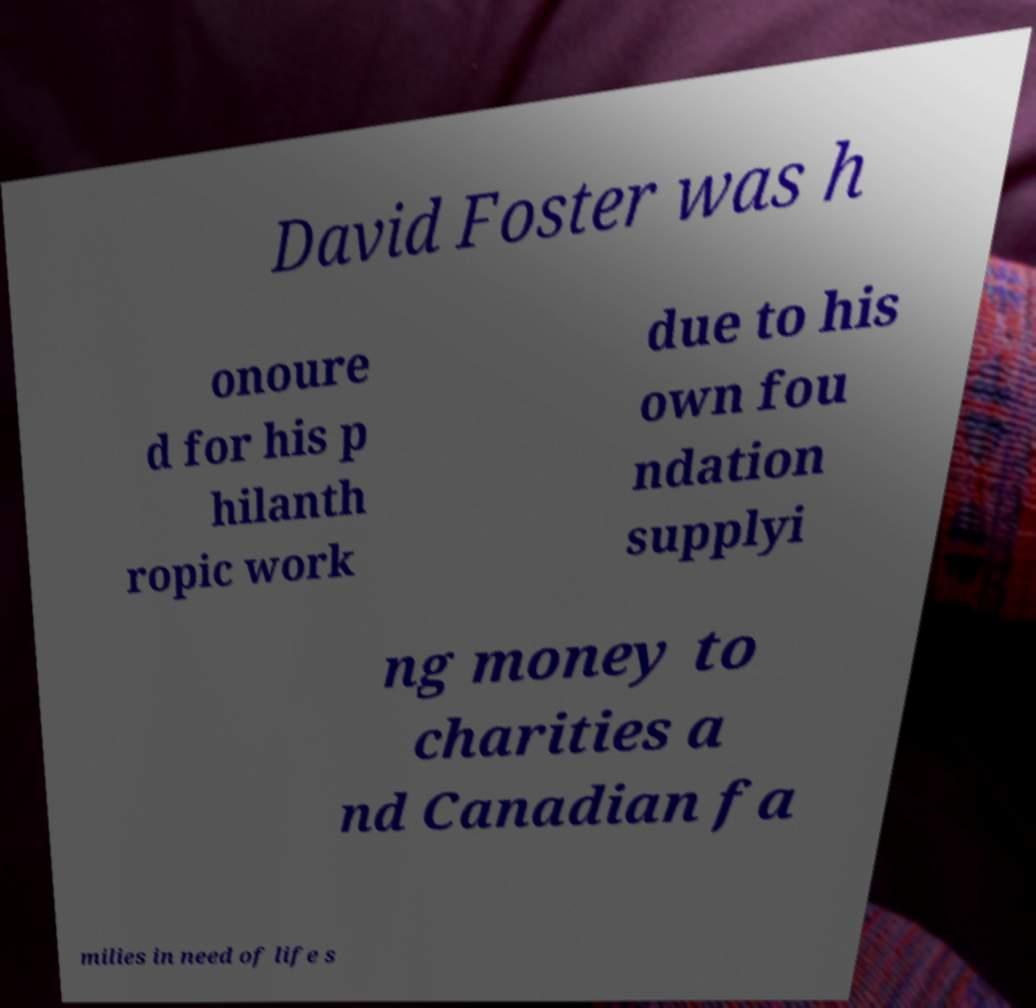I need the written content from this picture converted into text. Can you do that? David Foster was h onoure d for his p hilanth ropic work due to his own fou ndation supplyi ng money to charities a nd Canadian fa milies in need of life s 